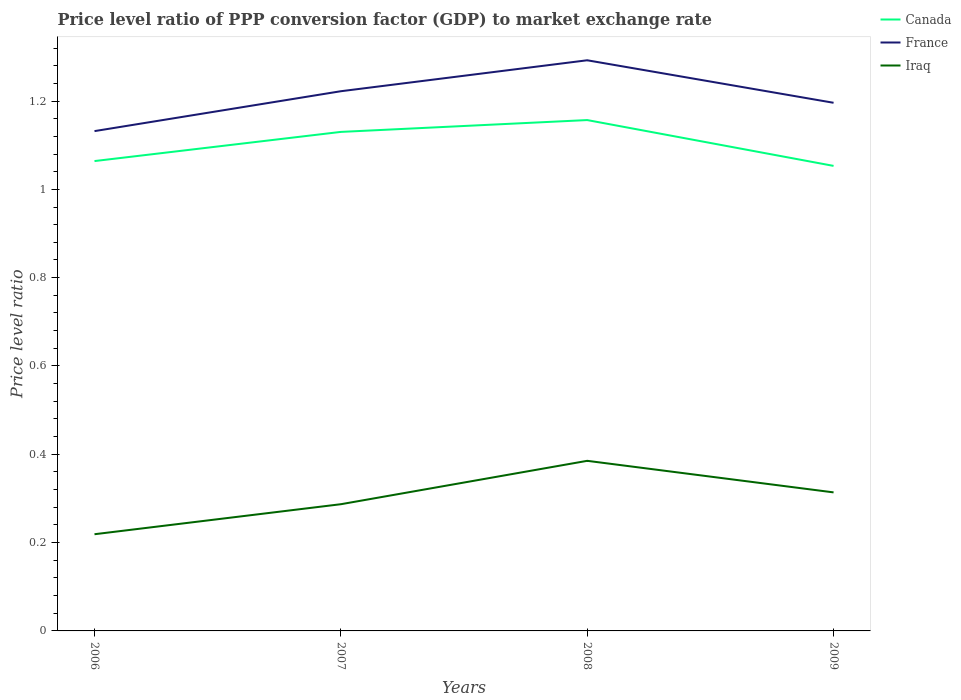How many different coloured lines are there?
Offer a terse response. 3. Is the number of lines equal to the number of legend labels?
Ensure brevity in your answer.  Yes. Across all years, what is the maximum price level ratio in Iraq?
Ensure brevity in your answer.  0.22. What is the total price level ratio in Canada in the graph?
Ensure brevity in your answer.  0.08. What is the difference between the highest and the second highest price level ratio in Canada?
Your answer should be compact. 0.1. What is the difference between the highest and the lowest price level ratio in Canada?
Your answer should be very brief. 2. Is the price level ratio in Iraq strictly greater than the price level ratio in Canada over the years?
Provide a short and direct response. Yes. How many lines are there?
Your answer should be very brief. 3. What is the difference between two consecutive major ticks on the Y-axis?
Your response must be concise. 0.2. Where does the legend appear in the graph?
Offer a very short reply. Top right. How many legend labels are there?
Offer a terse response. 3. What is the title of the graph?
Your answer should be very brief. Price level ratio of PPP conversion factor (GDP) to market exchange rate. Does "Mozambique" appear as one of the legend labels in the graph?
Provide a succinct answer. No. What is the label or title of the X-axis?
Offer a very short reply. Years. What is the label or title of the Y-axis?
Your answer should be very brief. Price level ratio. What is the Price level ratio in Canada in 2006?
Offer a terse response. 1.06. What is the Price level ratio in France in 2006?
Keep it short and to the point. 1.13. What is the Price level ratio in Iraq in 2006?
Your response must be concise. 0.22. What is the Price level ratio in Canada in 2007?
Offer a very short reply. 1.13. What is the Price level ratio of France in 2007?
Provide a short and direct response. 1.22. What is the Price level ratio in Iraq in 2007?
Provide a short and direct response. 0.29. What is the Price level ratio of Canada in 2008?
Offer a terse response. 1.16. What is the Price level ratio of France in 2008?
Give a very brief answer. 1.29. What is the Price level ratio in Iraq in 2008?
Keep it short and to the point. 0.39. What is the Price level ratio of Canada in 2009?
Provide a short and direct response. 1.05. What is the Price level ratio in France in 2009?
Provide a short and direct response. 1.2. What is the Price level ratio of Iraq in 2009?
Your answer should be compact. 0.31. Across all years, what is the maximum Price level ratio of Canada?
Offer a very short reply. 1.16. Across all years, what is the maximum Price level ratio of France?
Make the answer very short. 1.29. Across all years, what is the maximum Price level ratio in Iraq?
Keep it short and to the point. 0.39. Across all years, what is the minimum Price level ratio in Canada?
Give a very brief answer. 1.05. Across all years, what is the minimum Price level ratio of France?
Ensure brevity in your answer.  1.13. Across all years, what is the minimum Price level ratio of Iraq?
Keep it short and to the point. 0.22. What is the total Price level ratio in Canada in the graph?
Offer a terse response. 4.4. What is the total Price level ratio of France in the graph?
Your response must be concise. 4.84. What is the total Price level ratio in Iraq in the graph?
Make the answer very short. 1.2. What is the difference between the Price level ratio in Canada in 2006 and that in 2007?
Your response must be concise. -0.07. What is the difference between the Price level ratio of France in 2006 and that in 2007?
Offer a very short reply. -0.09. What is the difference between the Price level ratio of Iraq in 2006 and that in 2007?
Your response must be concise. -0.07. What is the difference between the Price level ratio in Canada in 2006 and that in 2008?
Your answer should be very brief. -0.09. What is the difference between the Price level ratio in France in 2006 and that in 2008?
Provide a succinct answer. -0.16. What is the difference between the Price level ratio in Iraq in 2006 and that in 2008?
Ensure brevity in your answer.  -0.17. What is the difference between the Price level ratio of Canada in 2006 and that in 2009?
Offer a very short reply. 0.01. What is the difference between the Price level ratio in France in 2006 and that in 2009?
Keep it short and to the point. -0.06. What is the difference between the Price level ratio of Iraq in 2006 and that in 2009?
Your answer should be compact. -0.09. What is the difference between the Price level ratio in Canada in 2007 and that in 2008?
Give a very brief answer. -0.03. What is the difference between the Price level ratio of France in 2007 and that in 2008?
Ensure brevity in your answer.  -0.07. What is the difference between the Price level ratio in Iraq in 2007 and that in 2008?
Provide a short and direct response. -0.1. What is the difference between the Price level ratio of Canada in 2007 and that in 2009?
Offer a very short reply. 0.08. What is the difference between the Price level ratio in France in 2007 and that in 2009?
Keep it short and to the point. 0.03. What is the difference between the Price level ratio of Iraq in 2007 and that in 2009?
Offer a very short reply. -0.03. What is the difference between the Price level ratio in Canada in 2008 and that in 2009?
Your response must be concise. 0.1. What is the difference between the Price level ratio in France in 2008 and that in 2009?
Your answer should be very brief. 0.1. What is the difference between the Price level ratio in Iraq in 2008 and that in 2009?
Provide a short and direct response. 0.07. What is the difference between the Price level ratio of Canada in 2006 and the Price level ratio of France in 2007?
Give a very brief answer. -0.16. What is the difference between the Price level ratio of Canada in 2006 and the Price level ratio of Iraq in 2007?
Provide a short and direct response. 0.78. What is the difference between the Price level ratio in France in 2006 and the Price level ratio in Iraq in 2007?
Ensure brevity in your answer.  0.84. What is the difference between the Price level ratio of Canada in 2006 and the Price level ratio of France in 2008?
Provide a succinct answer. -0.23. What is the difference between the Price level ratio in Canada in 2006 and the Price level ratio in Iraq in 2008?
Your answer should be compact. 0.68. What is the difference between the Price level ratio in France in 2006 and the Price level ratio in Iraq in 2008?
Offer a very short reply. 0.75. What is the difference between the Price level ratio in Canada in 2006 and the Price level ratio in France in 2009?
Your answer should be compact. -0.13. What is the difference between the Price level ratio in Canada in 2006 and the Price level ratio in Iraq in 2009?
Make the answer very short. 0.75. What is the difference between the Price level ratio of France in 2006 and the Price level ratio of Iraq in 2009?
Provide a succinct answer. 0.82. What is the difference between the Price level ratio in Canada in 2007 and the Price level ratio in France in 2008?
Provide a short and direct response. -0.16. What is the difference between the Price level ratio in Canada in 2007 and the Price level ratio in Iraq in 2008?
Give a very brief answer. 0.74. What is the difference between the Price level ratio of France in 2007 and the Price level ratio of Iraq in 2008?
Your answer should be compact. 0.84. What is the difference between the Price level ratio of Canada in 2007 and the Price level ratio of France in 2009?
Your answer should be very brief. -0.07. What is the difference between the Price level ratio of Canada in 2007 and the Price level ratio of Iraq in 2009?
Offer a terse response. 0.82. What is the difference between the Price level ratio of France in 2007 and the Price level ratio of Iraq in 2009?
Provide a succinct answer. 0.91. What is the difference between the Price level ratio in Canada in 2008 and the Price level ratio in France in 2009?
Offer a terse response. -0.04. What is the difference between the Price level ratio of Canada in 2008 and the Price level ratio of Iraq in 2009?
Provide a short and direct response. 0.84. What is the difference between the Price level ratio in France in 2008 and the Price level ratio in Iraq in 2009?
Provide a short and direct response. 0.98. What is the average Price level ratio in Canada per year?
Your answer should be very brief. 1.1. What is the average Price level ratio of France per year?
Your response must be concise. 1.21. What is the average Price level ratio of Iraq per year?
Give a very brief answer. 0.3. In the year 2006, what is the difference between the Price level ratio in Canada and Price level ratio in France?
Provide a short and direct response. -0.07. In the year 2006, what is the difference between the Price level ratio in Canada and Price level ratio in Iraq?
Provide a short and direct response. 0.85. In the year 2006, what is the difference between the Price level ratio in France and Price level ratio in Iraq?
Your response must be concise. 0.91. In the year 2007, what is the difference between the Price level ratio of Canada and Price level ratio of France?
Provide a short and direct response. -0.09. In the year 2007, what is the difference between the Price level ratio of Canada and Price level ratio of Iraq?
Your answer should be compact. 0.84. In the year 2007, what is the difference between the Price level ratio of France and Price level ratio of Iraq?
Ensure brevity in your answer.  0.94. In the year 2008, what is the difference between the Price level ratio in Canada and Price level ratio in France?
Provide a succinct answer. -0.14. In the year 2008, what is the difference between the Price level ratio in Canada and Price level ratio in Iraq?
Offer a very short reply. 0.77. In the year 2008, what is the difference between the Price level ratio of France and Price level ratio of Iraq?
Make the answer very short. 0.91. In the year 2009, what is the difference between the Price level ratio in Canada and Price level ratio in France?
Make the answer very short. -0.14. In the year 2009, what is the difference between the Price level ratio in Canada and Price level ratio in Iraq?
Make the answer very short. 0.74. In the year 2009, what is the difference between the Price level ratio in France and Price level ratio in Iraq?
Keep it short and to the point. 0.88. What is the ratio of the Price level ratio of Canada in 2006 to that in 2007?
Your response must be concise. 0.94. What is the ratio of the Price level ratio in France in 2006 to that in 2007?
Your answer should be very brief. 0.93. What is the ratio of the Price level ratio in Iraq in 2006 to that in 2007?
Ensure brevity in your answer.  0.76. What is the ratio of the Price level ratio in Canada in 2006 to that in 2008?
Offer a very short reply. 0.92. What is the ratio of the Price level ratio of France in 2006 to that in 2008?
Offer a terse response. 0.88. What is the ratio of the Price level ratio of Iraq in 2006 to that in 2008?
Your answer should be compact. 0.57. What is the ratio of the Price level ratio in Canada in 2006 to that in 2009?
Give a very brief answer. 1.01. What is the ratio of the Price level ratio of France in 2006 to that in 2009?
Your answer should be very brief. 0.95. What is the ratio of the Price level ratio of Iraq in 2006 to that in 2009?
Provide a short and direct response. 0.7. What is the ratio of the Price level ratio of Canada in 2007 to that in 2008?
Offer a terse response. 0.98. What is the ratio of the Price level ratio in France in 2007 to that in 2008?
Keep it short and to the point. 0.95. What is the ratio of the Price level ratio of Iraq in 2007 to that in 2008?
Offer a very short reply. 0.74. What is the ratio of the Price level ratio in Canada in 2007 to that in 2009?
Ensure brevity in your answer.  1.07. What is the ratio of the Price level ratio of France in 2007 to that in 2009?
Your answer should be very brief. 1.02. What is the ratio of the Price level ratio of Iraq in 2007 to that in 2009?
Ensure brevity in your answer.  0.91. What is the ratio of the Price level ratio in Canada in 2008 to that in 2009?
Provide a succinct answer. 1.1. What is the ratio of the Price level ratio of France in 2008 to that in 2009?
Give a very brief answer. 1.08. What is the ratio of the Price level ratio in Iraq in 2008 to that in 2009?
Keep it short and to the point. 1.23. What is the difference between the highest and the second highest Price level ratio in Canada?
Keep it short and to the point. 0.03. What is the difference between the highest and the second highest Price level ratio in France?
Ensure brevity in your answer.  0.07. What is the difference between the highest and the second highest Price level ratio in Iraq?
Provide a succinct answer. 0.07. What is the difference between the highest and the lowest Price level ratio in Canada?
Ensure brevity in your answer.  0.1. What is the difference between the highest and the lowest Price level ratio in France?
Make the answer very short. 0.16. What is the difference between the highest and the lowest Price level ratio of Iraq?
Provide a succinct answer. 0.17. 